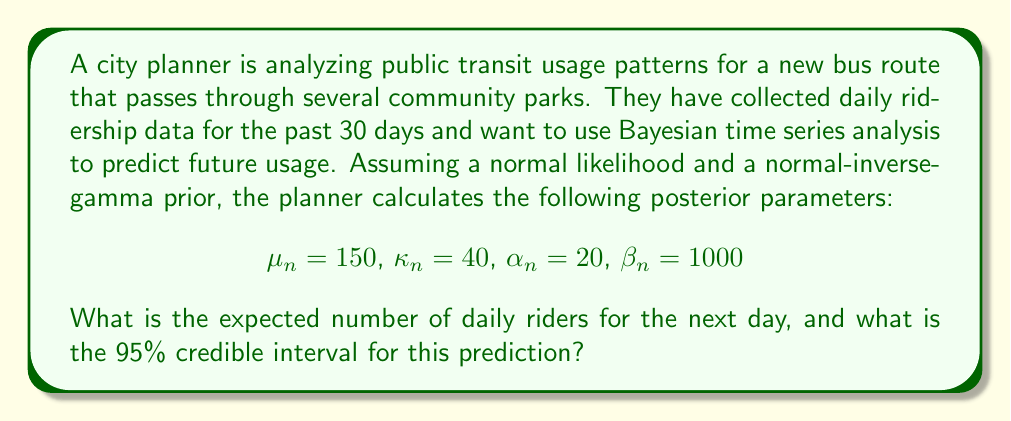Solve this math problem. To solve this problem, we'll use the posterior predictive distribution from Bayesian time series analysis with a normal likelihood and normal-inverse-gamma prior.

1. Expected number of daily riders:
   The expected value of the posterior predictive distribution is equal to the posterior mean $\mu_n$. Therefore, the expected number of daily riders for the next day is 150.

2. 95% credible interval:
   To calculate the credible interval, we need to use the t-distribution with degrees of freedom $2\alpha_n$ and scale parameter $\sqrt{\frac{\beta_n(\kappa_n + 1)}{\alpha_n \kappa_n}}$.

   Steps:
   a) Calculate degrees of freedom: $df = 2\alpha_n = 2(20) = 40$
   
   b) Calculate scale parameter:
      $s = \sqrt{\frac{\beta_n(\kappa_n + 1)}{\alpha_n \kappa_n}} = \sqrt{\frac{1000(40 + 1)}{20 \cdot 40}} = \sqrt{51.25} \approx 7.16$
   
   c) Find the t-value for a 95% credible interval with 40 degrees of freedom:
      $t_{0.975, 40} \approx 2.021$ (using a t-distribution table or calculator)
   
   d) Calculate the credible interval:
      Lower bound: $150 - (2.021 \cdot 7.16) \approx 135.5$
      Upper bound: $150 + (2.021 \cdot 7.16) \approx 164.5$

Therefore, the 95% credible interval for the next day's ridership is approximately (135.5, 164.5).
Answer: Expected number of daily riders: 150
95% credible interval: (135.5, 164.5) 